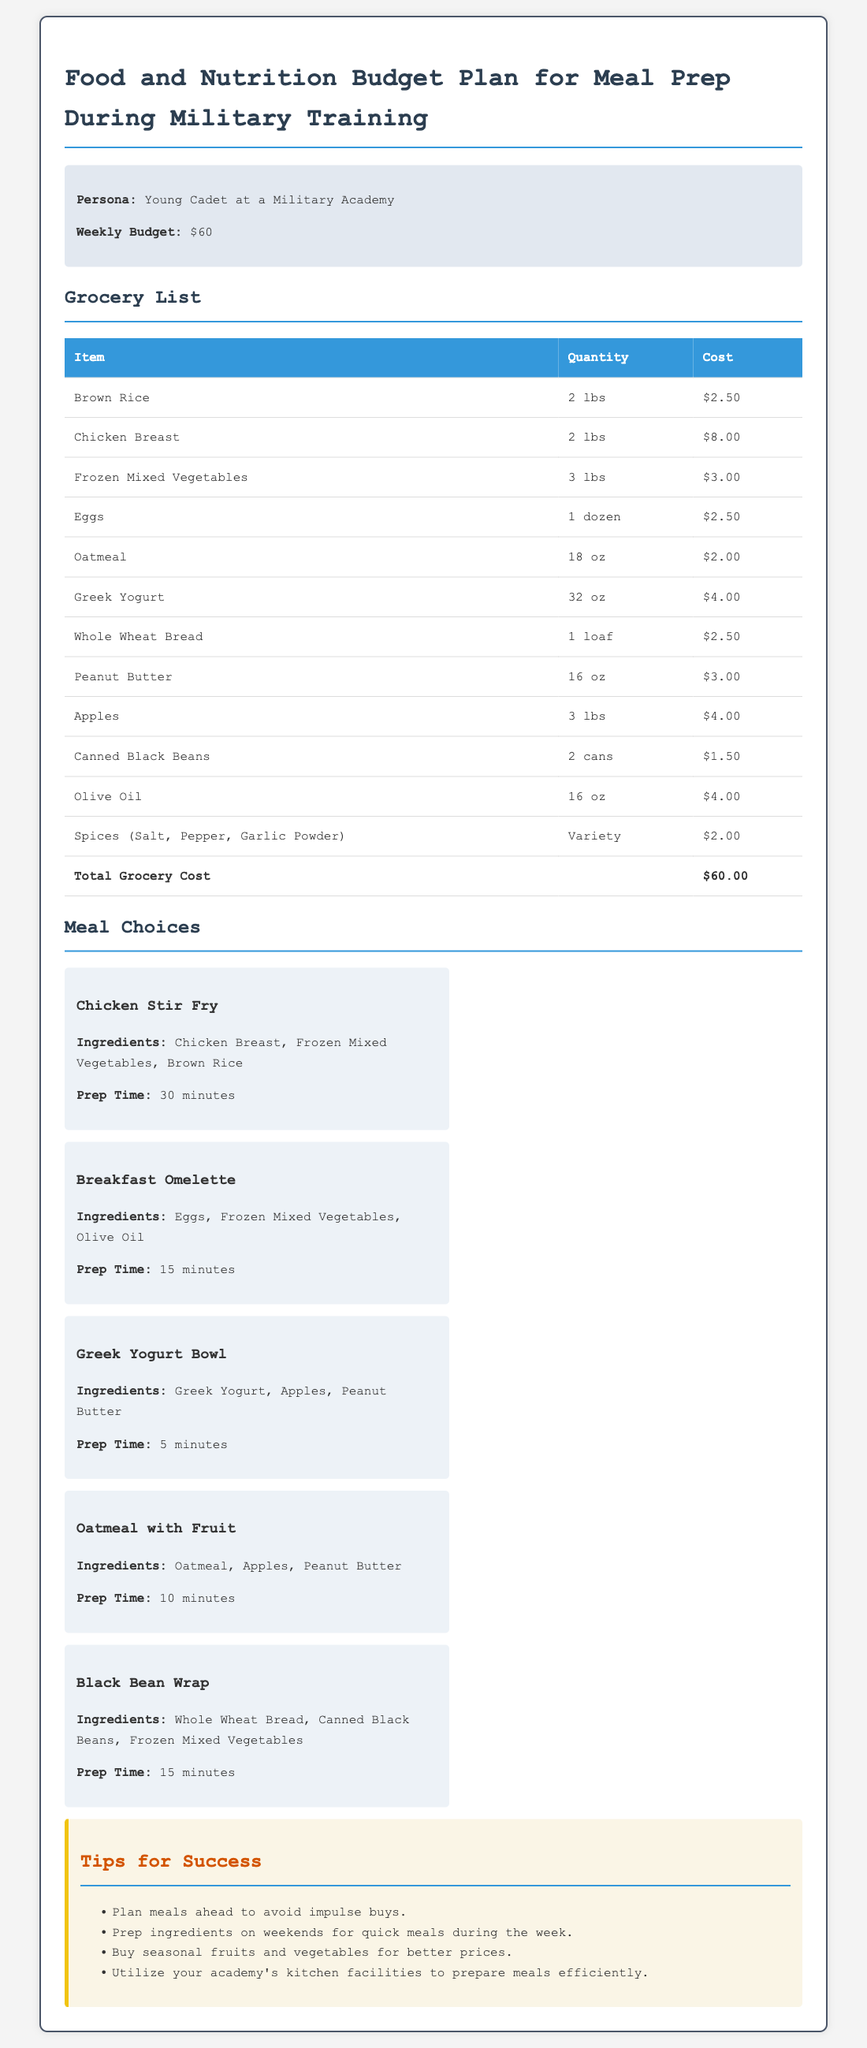What is the weekly budget? The document states the weekly budget set for meal prep is $60.
Answer: $60 What is the cost of Chicken Breast? The document lists the cost for Chicken Breast as $8.00.
Answer: $8.00 How much does a dozen Eggs cost? The cost for a dozen Eggs is provided as $2.50 in the grocery list.
Answer: $2.50 What meal takes the least amount of prep time? The Greek Yogurt Bowl requires only 5 minutes of prep time according to the meal choices.
Answer: 5 minutes How many pounds of Brown Rice are purchased? The grocery list indicates that 2 lbs of Brown Rice are purchased.
Answer: 2 lbs What ingredients are used in the Chicken Stir Fry? The document specifies Chicken Breast, Frozen Mixed Vegetables, and Brown Rice as the ingredients for Chicken Stir Fry.
Answer: Chicken Breast, Frozen Mixed Vegetables, Brown Rice Which meal uses Whole Wheat Bread? The Black Bean Wrap is the meal that uses Whole Wheat Bread as per the meal choices section.
Answer: Black Bean Wrap What is the total cost listed for all groceries? The total grocery cost is stated as $60.00 in the document footer.
Answer: $60.00 What is one tip provided for success? One tip listed is to plan meals ahead to avoid impulse buys.
Answer: Plan meals ahead to avoid impulse buys 